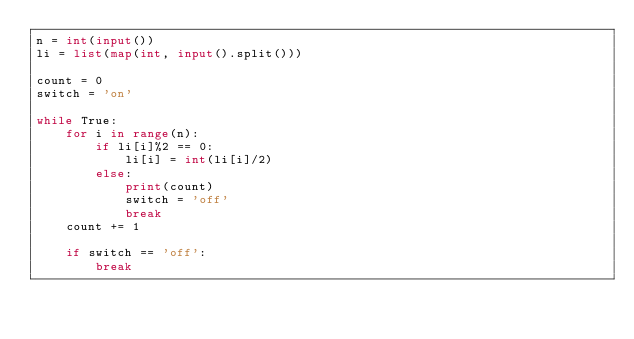Convert code to text. <code><loc_0><loc_0><loc_500><loc_500><_Python_>n = int(input())
li = list(map(int, input().split()))

count = 0
switch = 'on'

while True:
    for i in range(n):
        if li[i]%2 == 0:
            li[i] = int(li[i]/2)
        else:
            print(count)
            switch = 'off'
            break
    count += 1

    if switch == 'off':
        break
</code> 